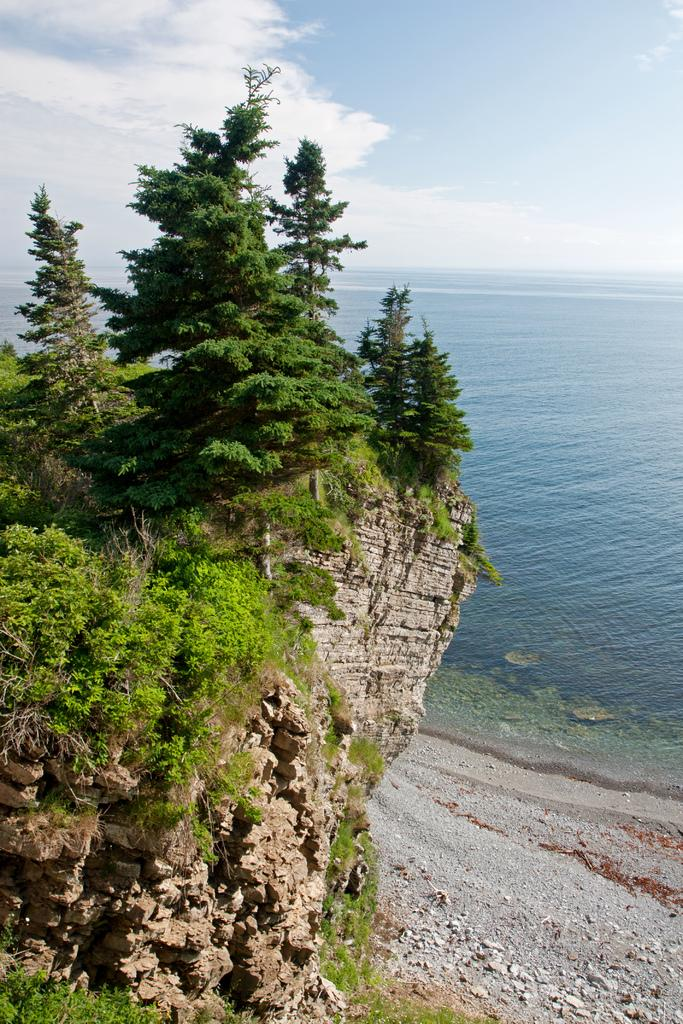What type of living organisms can be seen in the image? Plants can be seen in the image. What other elements are present in the image besides plants? There are rocks and water visible in the image. What can be seen in the background of the image? The sky is visible in the background of the image. Where is the playground located in the image? There is no playground present in the image. How many drops of water can be seen falling from the sky in the image? There is no indication of rain or falling water in the image, so it is not possible to determine the number of drops. 